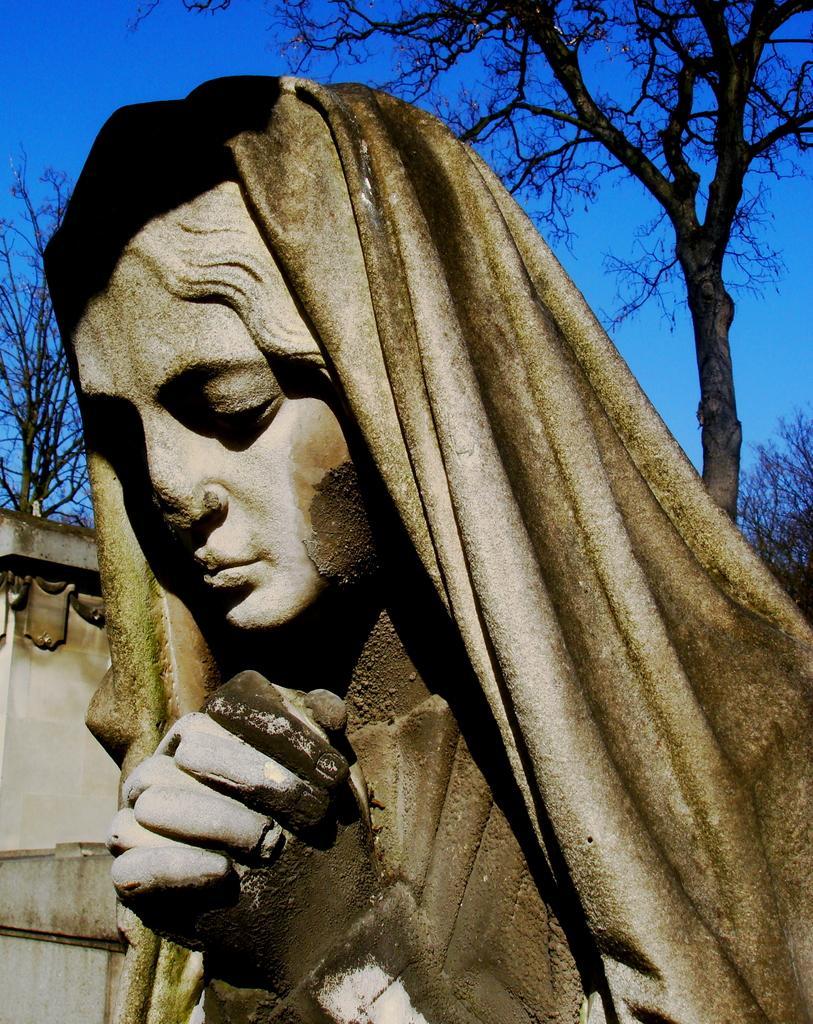Could you give a brief overview of what you see in this image? In this image, I can see the sculpture of the woman with a cloth. These are the trees. This looks like a wall. 